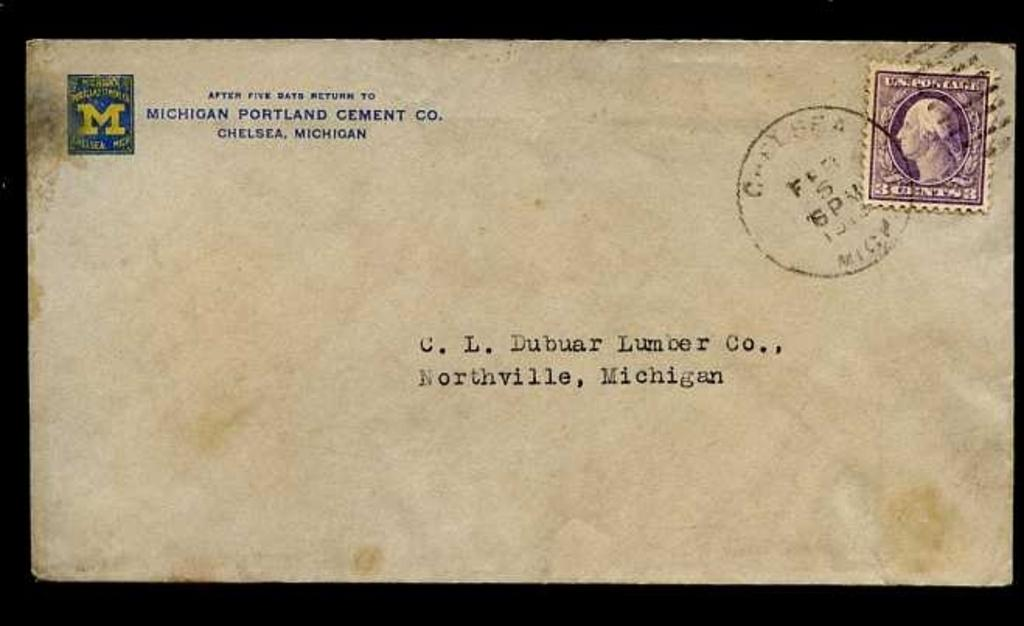<image>
Write a terse but informative summary of the picture. an envelop with a stamp and addressed to C. L. Dubuar Lumber Co. 